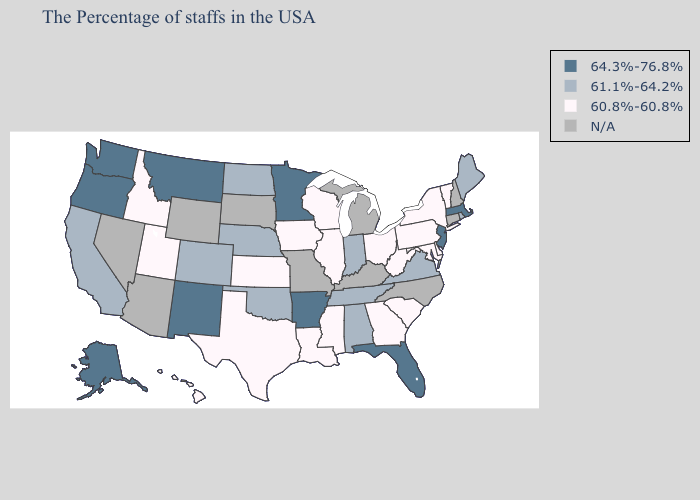Name the states that have a value in the range 64.3%-76.8%?
Give a very brief answer. Massachusetts, New Jersey, Florida, Arkansas, Minnesota, New Mexico, Montana, Washington, Oregon, Alaska. Among the states that border New Mexico , does Colorado have the lowest value?
Be succinct. No. Does the first symbol in the legend represent the smallest category?
Quick response, please. No. Name the states that have a value in the range 64.3%-76.8%?
Short answer required. Massachusetts, New Jersey, Florida, Arkansas, Minnesota, New Mexico, Montana, Washington, Oregon, Alaska. Name the states that have a value in the range 64.3%-76.8%?
Be succinct. Massachusetts, New Jersey, Florida, Arkansas, Minnesota, New Mexico, Montana, Washington, Oregon, Alaska. Name the states that have a value in the range 64.3%-76.8%?
Answer briefly. Massachusetts, New Jersey, Florida, Arkansas, Minnesota, New Mexico, Montana, Washington, Oregon, Alaska. What is the highest value in the USA?
Give a very brief answer. 64.3%-76.8%. What is the value of New Mexico?
Answer briefly. 64.3%-76.8%. Does the first symbol in the legend represent the smallest category?
Quick response, please. No. What is the value of Wyoming?
Quick response, please. N/A. What is the value of Colorado?
Short answer required. 61.1%-64.2%. How many symbols are there in the legend?
Write a very short answer. 4. Name the states that have a value in the range 64.3%-76.8%?
Short answer required. Massachusetts, New Jersey, Florida, Arkansas, Minnesota, New Mexico, Montana, Washington, Oregon, Alaska. What is the value of Idaho?
Short answer required. 60.8%-60.8%. What is the value of Arizona?
Write a very short answer. N/A. 